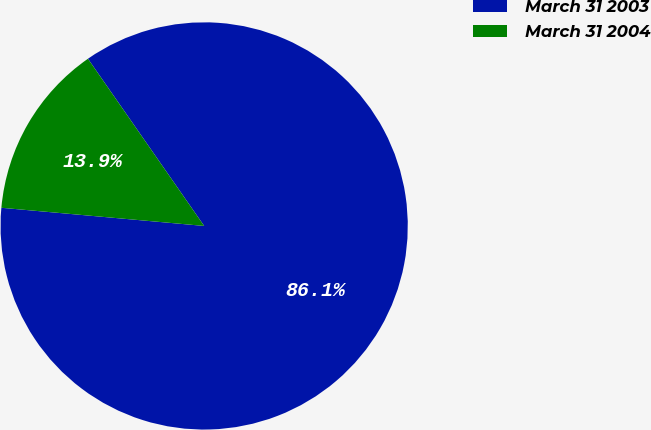Convert chart to OTSL. <chart><loc_0><loc_0><loc_500><loc_500><pie_chart><fcel>March 31 2003<fcel>March 31 2004<nl><fcel>86.09%<fcel>13.91%<nl></chart> 